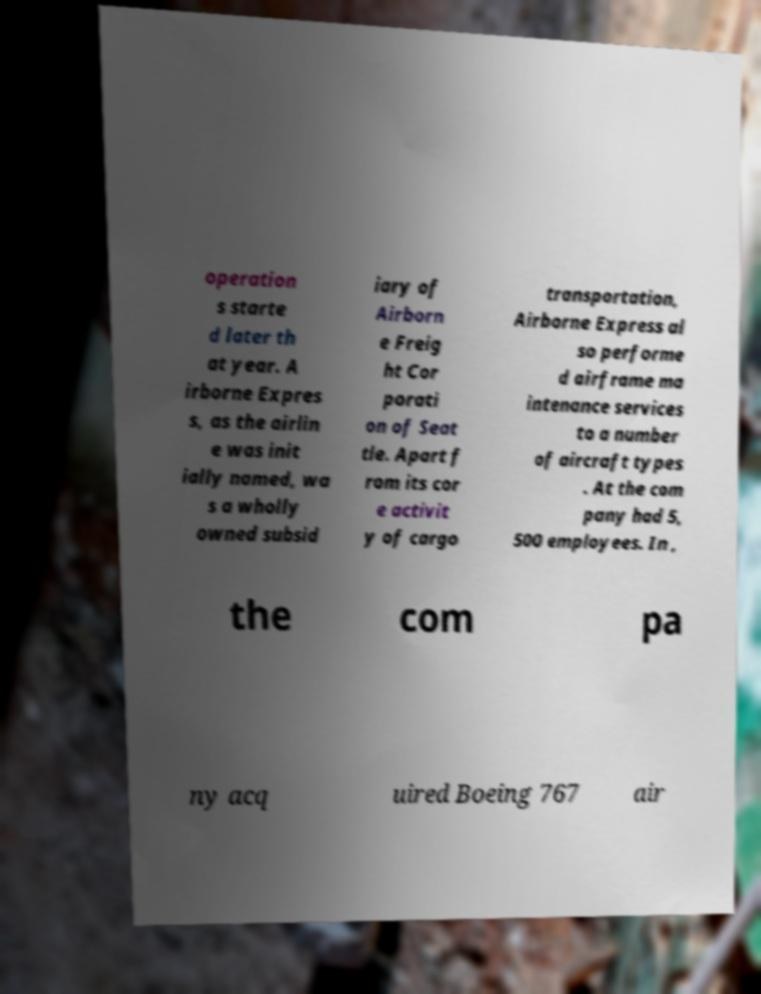I need the written content from this picture converted into text. Can you do that? operation s starte d later th at year. A irborne Expres s, as the airlin e was init ially named, wa s a wholly owned subsid iary of Airborn e Freig ht Cor porati on of Seat tle. Apart f rom its cor e activit y of cargo transportation, Airborne Express al so performe d airframe ma intenance services to a number of aircraft types . At the com pany had 5, 500 employees. In , the com pa ny acq uired Boeing 767 air 